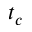<formula> <loc_0><loc_0><loc_500><loc_500>t _ { c }</formula> 